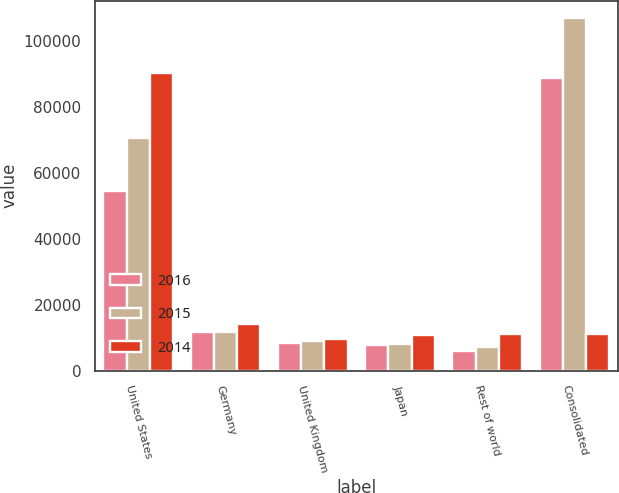Convert chart to OTSL. <chart><loc_0><loc_0><loc_500><loc_500><stacked_bar_chart><ecel><fcel>United States<fcel>Germany<fcel>United Kingdom<fcel>Japan<fcel>Rest of world<fcel>Consolidated<nl><fcel>2016<fcel>54717<fcel>11919<fcel>8341<fcel>7912<fcel>6099<fcel>88988<nl><fcel>2015<fcel>70537<fcel>11816<fcel>9033<fcel>8264<fcel>7356<fcel>107006<nl><fcel>2014<fcel>90349<fcel>14148<fcel>9547<fcel>10797<fcel>11146<fcel>11146<nl></chart> 